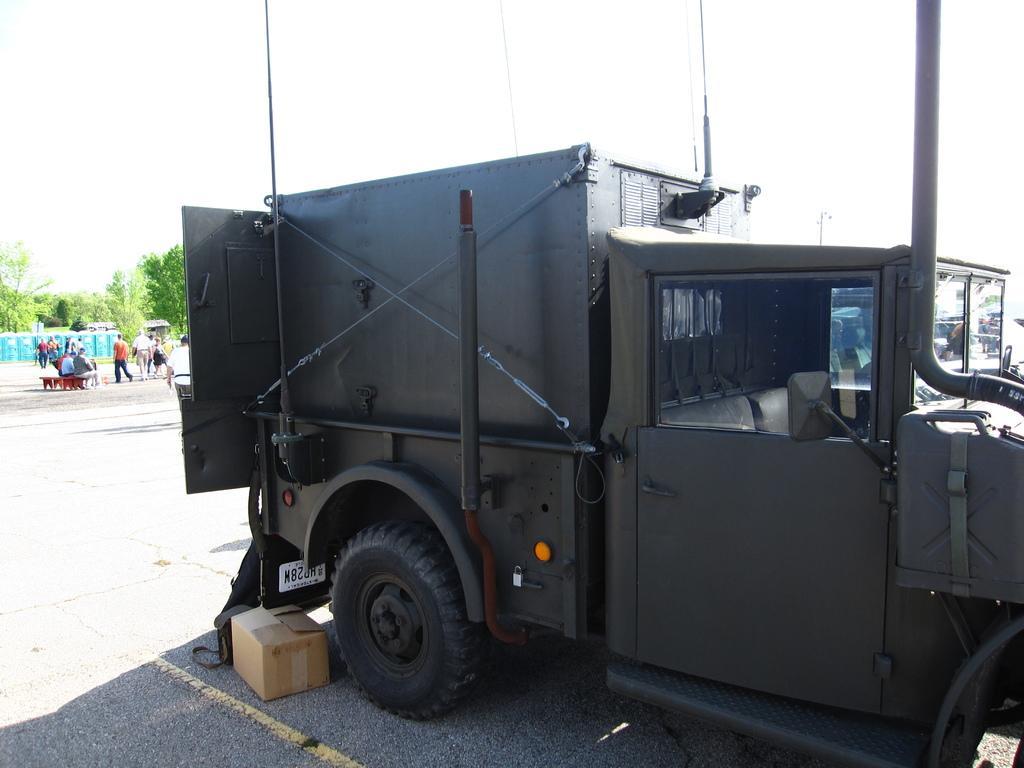Please provide a concise description of this image. In this image we can see a vehicle and box on the road. And there are a few people sitting on the bench and a few people walking. There are trees and sky. 